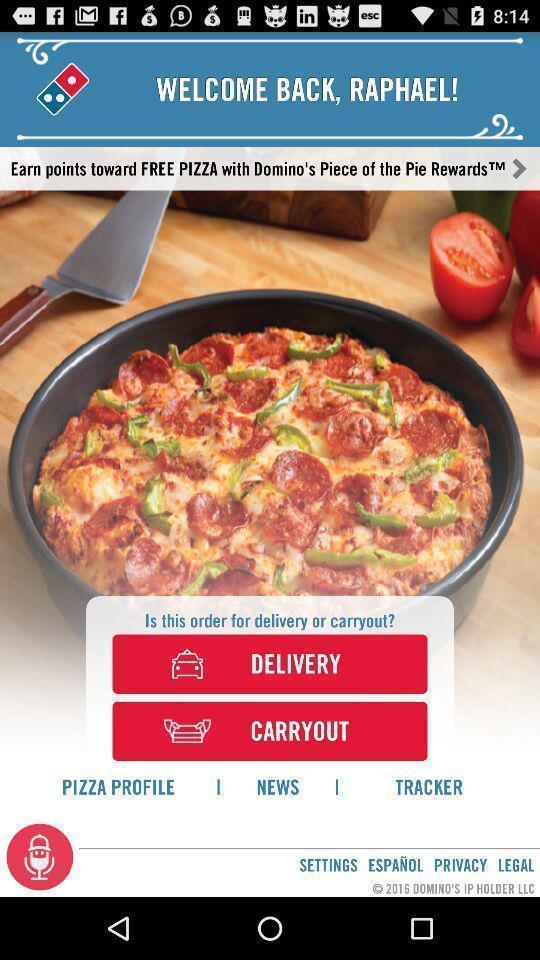Please provide a description for this image. Welcome page of a food application. 